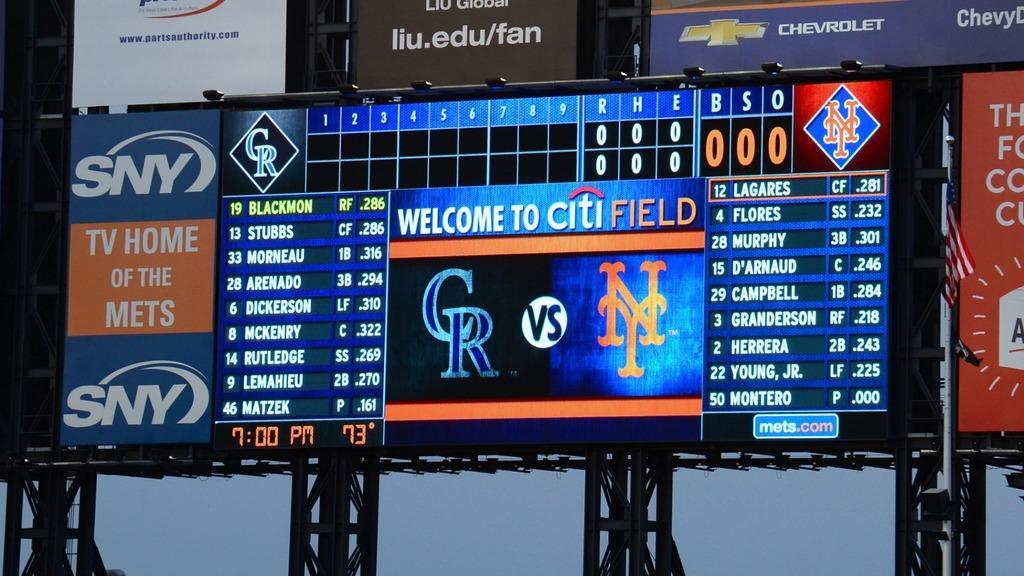Can you describe this image briefly? In the center of the image there is a screen and posters. In the background there is a sky. 